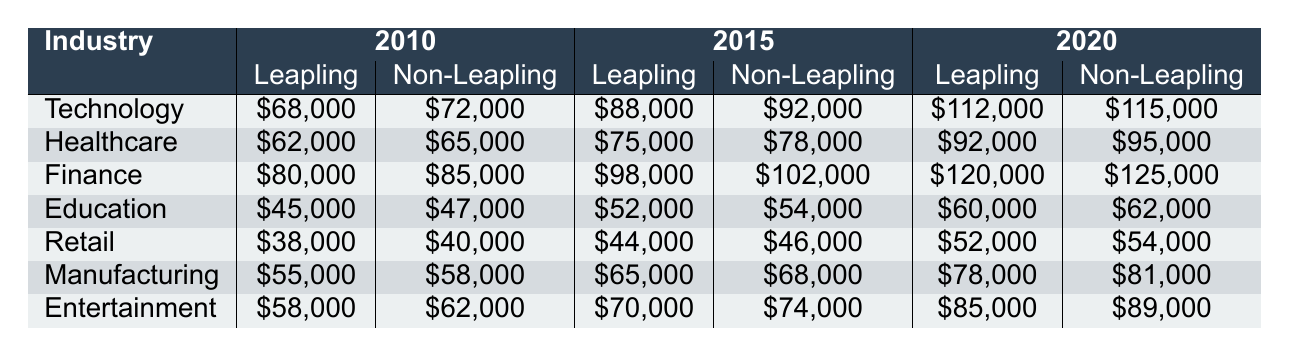What was the average salary discrepancy for leaplings in the Technology industry in 2010? The leapling average salary in Technology for 2010 is $68,000, and the non-leapling average salary is $72,000. The discrepancy is $72,000 - $68,000 = $4,000.
Answer: $4,000 In which industry did leaplings experience the highest average salary in 2020? The average salaries for leaplings in 2020 across industries are: Technology ($112,000), Healthcare ($92,000), Finance ($120,000), Education ($60,000), Retail ($52,000), Manufacturing ($78,000), and Entertainment ($85,000). The highest is $120,000 in Finance.
Answer: Finance True or False: Leaplings had a higher average salary than non-leaplings in any industry in 2015. In 2015, leapling salaries compared to non-leapling salaries are as follows: Technology ($88,000 vs $92,000), Healthcare ($75,000 vs $78,000), Finance ($98,000 vs $102,000), Education ($52,000 vs $54,000), Retail ($44,000 vs $46,000), Manufacturing ($65,000 vs $68,000), Entertainment ($70,000 vs $74,000). In all cases, leaplings earned less, so the statement is false.
Answer: False What was the total average salary for leaplings across all industries in 2020? The average salaries for leaplings in 2020 are: Technology ($112,000), Healthcare ($92,000), Finance ($120,000), Education ($60,000), Retail ($52,000), Manufacturing ($78,000), and Entertainment ($85,000). Summing these gives: $112,000 + $92,000 + $120,000 + $60,000 + $52,000 + $78,000 + $85,000 = $639,000. Dividing by 7 industries gives an average of $639,000 / 7 = $91,285.71.
Answer: $91,285.71 Which industry saw the smallest average salary increase for leaplings from 2010 to 2020? The salary increases for leaplings from 2010 to 2020 are: Technology ($68,000 to $112,000 = $44,000), Healthcare ($62,000 to $92,000 = $30,000), Finance ($80,000 to $120,000 = $40,000), Education ($45,000 to $60,000 = $15,000), Retail ($38,000 to $52,000 = $14,000), Manufacturing ($55,000 to $78,000 = $23,000), and Entertainment ($58,000 to $85,000 = $27,000). The smallest increase is $14,000 in Retail.
Answer: Retail Did the average salary for leaplings in Healthcare exceed $70,000 in 2020? The leapling average salary in Healthcare for 2020 is $92,000, which is greater than $70,000. Thus, the answer is true.
Answer: True What was the overall trend for salary discrepancies between leaplings and non-leaplings from 2010 to 2020 in the Finance industry? The discrepancy for leaplings vs non-leaplings in Finance was $5,000 in 2010, $4,000 in 2015, and $5,000 in 2020. This indicates that the gap decreased from 2010 to 2015 but then returned to the same discrepancy level by 2020, showing an inconsistent trend.
Answer: The trend decreased then stayed the same 